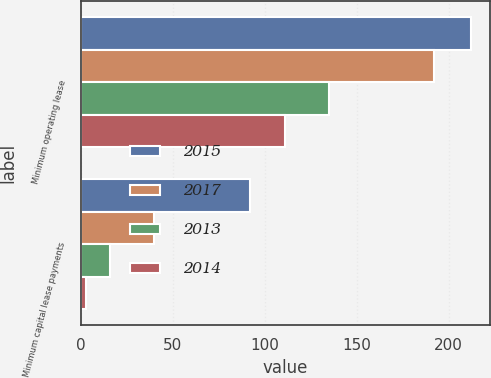<chart> <loc_0><loc_0><loc_500><loc_500><stacked_bar_chart><ecel><fcel>Minimum operating lease<fcel>Minimum capital lease payments<nl><fcel>2015<fcel>212<fcel>92<nl><fcel>2017<fcel>192<fcel>40<nl><fcel>2013<fcel>135<fcel>16<nl><fcel>2014<fcel>111<fcel>3<nl></chart> 